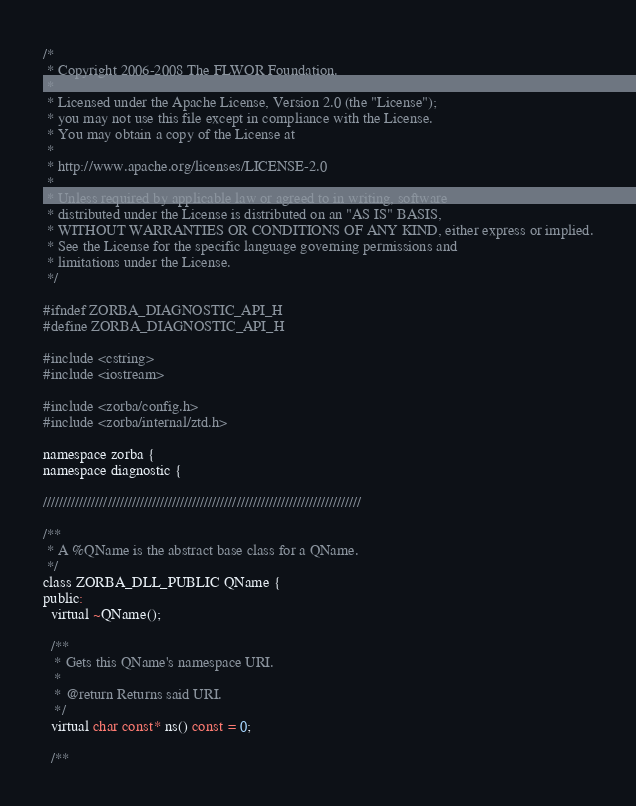Convert code to text. <code><loc_0><loc_0><loc_500><loc_500><_C_>/*
 * Copyright 2006-2008 The FLWOR Foundation.
 * 
 * Licensed under the Apache License, Version 2.0 (the "License");
 * you may not use this file except in compliance with the License.
 * You may obtain a copy of the License at
 * 
 * http://www.apache.org/licenses/LICENSE-2.0
 * 
 * Unless required by applicable law or agreed to in writing, software
 * distributed under the License is distributed on an "AS IS" BASIS,
 * WITHOUT WARRANTIES OR CONDITIONS OF ANY KIND, either express or implied.
 * See the License for the specific language governing permissions and
 * limitations under the License.
 */

#ifndef ZORBA_DIAGNOSTIC_API_H
#define ZORBA_DIAGNOSTIC_API_H

#include <cstring>
#include <iostream>

#include <zorba/config.h>
#include <zorba/internal/ztd.h>

namespace zorba {
namespace diagnostic {

///////////////////////////////////////////////////////////////////////////////

/**
 * A %QName is the abstract base class for a QName.
 */
class ZORBA_DLL_PUBLIC QName {
public:
  virtual ~QName();

  /**
   * Gets this QName's namespace URI.
   *
   * @return Returns said URI.
   */
  virtual char const* ns() const = 0;

  /**</code> 